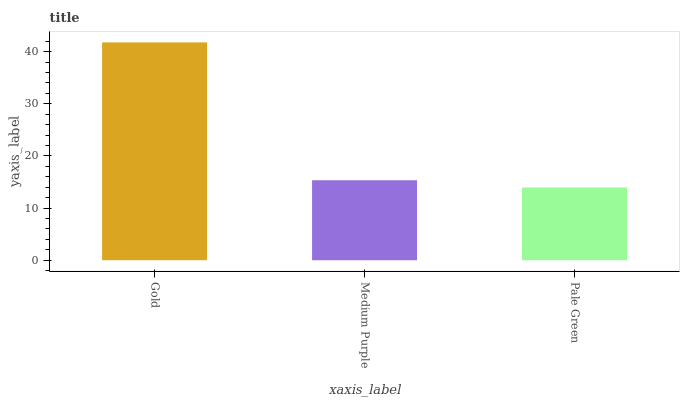Is Medium Purple the minimum?
Answer yes or no. No. Is Medium Purple the maximum?
Answer yes or no. No. Is Gold greater than Medium Purple?
Answer yes or no. Yes. Is Medium Purple less than Gold?
Answer yes or no. Yes. Is Medium Purple greater than Gold?
Answer yes or no. No. Is Gold less than Medium Purple?
Answer yes or no. No. Is Medium Purple the high median?
Answer yes or no. Yes. Is Medium Purple the low median?
Answer yes or no. Yes. Is Gold the high median?
Answer yes or no. No. Is Gold the low median?
Answer yes or no. No. 